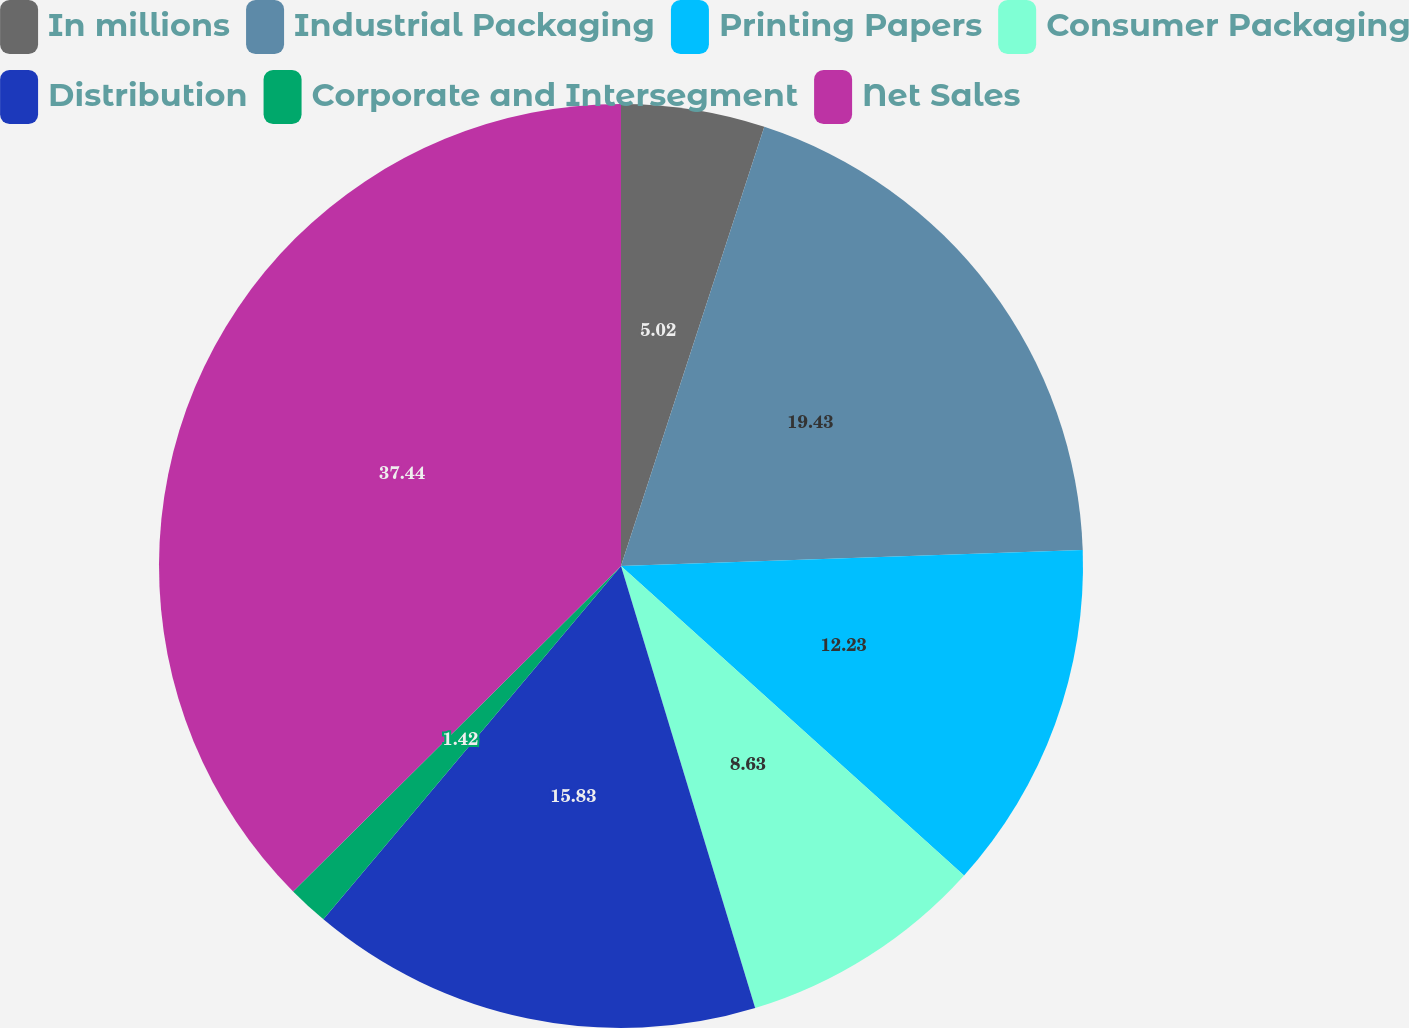Convert chart. <chart><loc_0><loc_0><loc_500><loc_500><pie_chart><fcel>In millions<fcel>Industrial Packaging<fcel>Printing Papers<fcel>Consumer Packaging<fcel>Distribution<fcel>Corporate and Intersegment<fcel>Net Sales<nl><fcel>5.02%<fcel>19.43%<fcel>12.23%<fcel>8.63%<fcel>15.83%<fcel>1.42%<fcel>37.44%<nl></chart> 